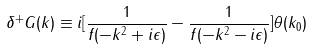<formula> <loc_0><loc_0><loc_500><loc_500>\delta ^ { + } G ( k ) \equiv i [ \frac { 1 } { f ( - k ^ { 2 } + i \epsilon ) } - \frac { 1 } { f ( - k ^ { 2 } - i \epsilon ) } ] \theta ( k _ { 0 } )</formula> 